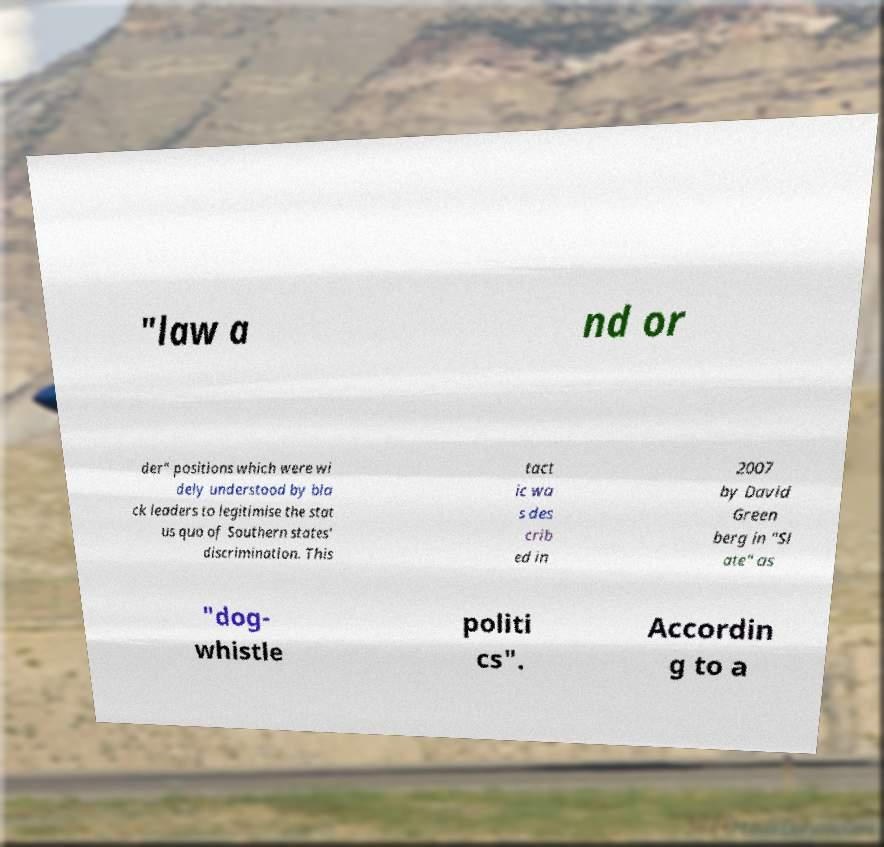Can you accurately transcribe the text from the provided image for me? "law a nd or der" positions which were wi dely understood by bla ck leaders to legitimise the stat us quo of Southern states' discrimination. This tact ic wa s des crib ed in 2007 by David Green berg in "Sl ate" as "dog- whistle politi cs". Accordin g to a 